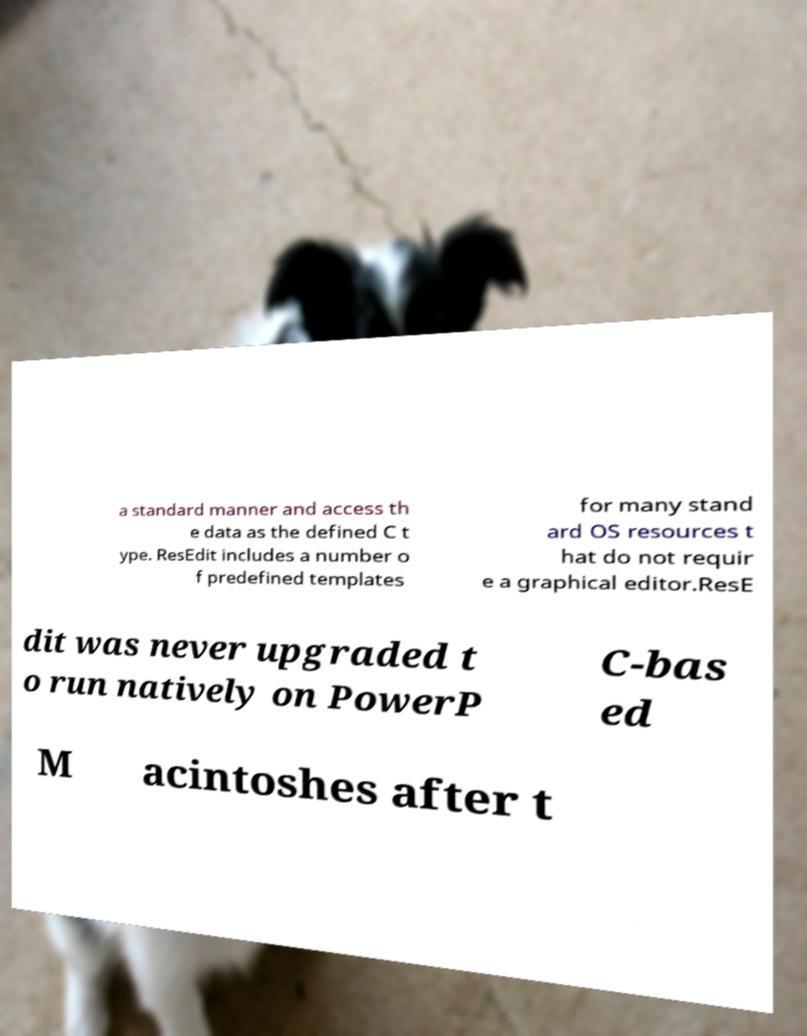What messages or text are displayed in this image? I need them in a readable, typed format. a standard manner and access th e data as the defined C t ype. ResEdit includes a number o f predefined templates for many stand ard OS resources t hat do not requir e a graphical editor.ResE dit was never upgraded t o run natively on PowerP C-bas ed M acintoshes after t 